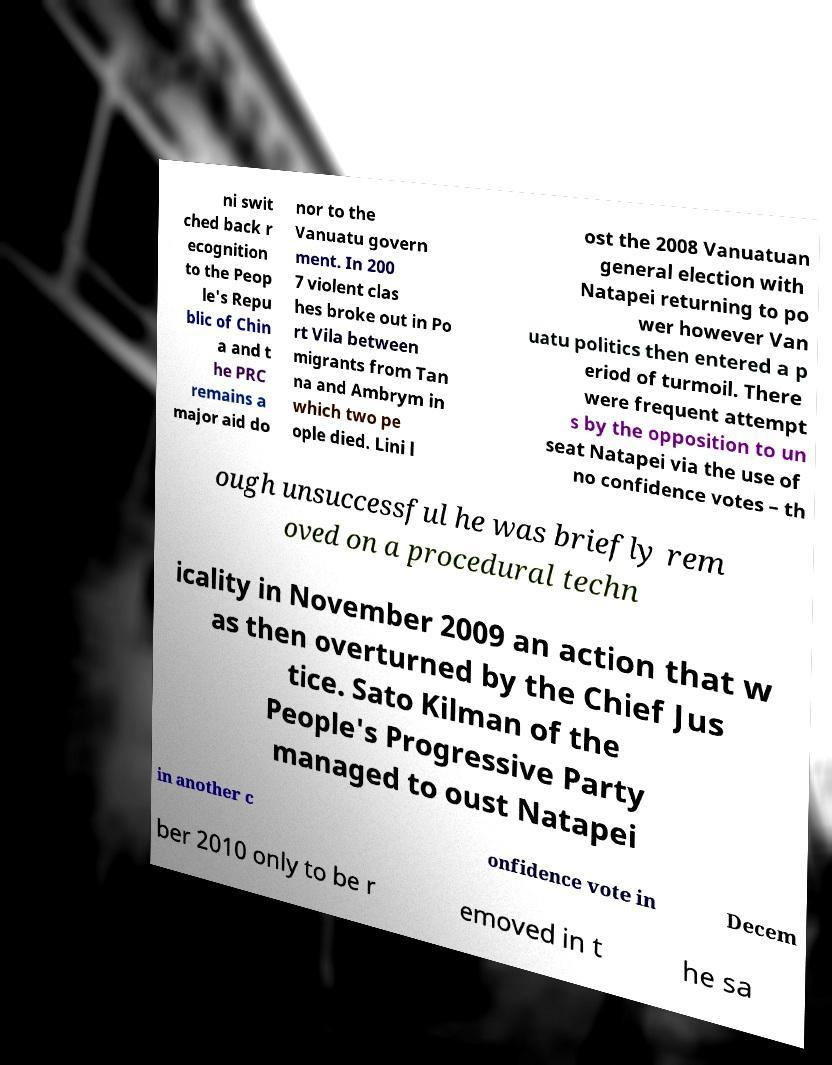What messages or text are displayed in this image? I need them in a readable, typed format. ni swit ched back r ecognition to the Peop le's Repu blic of Chin a and t he PRC remains a major aid do nor to the Vanuatu govern ment. In 200 7 violent clas hes broke out in Po rt Vila between migrants from Tan na and Ambrym in which two pe ople died. Lini l ost the 2008 Vanuatuan general election with Natapei returning to po wer however Van uatu politics then entered a p eriod of turmoil. There were frequent attempt s by the opposition to un seat Natapei via the use of no confidence votes – th ough unsuccessful he was briefly rem oved on a procedural techn icality in November 2009 an action that w as then overturned by the Chief Jus tice. Sato Kilman of the People's Progressive Party managed to oust Natapei in another c onfidence vote in Decem ber 2010 only to be r emoved in t he sa 